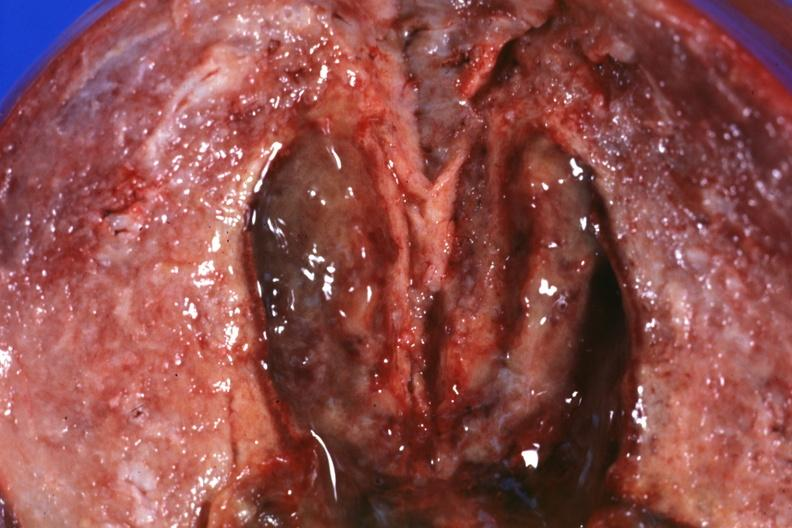s endometritis present?
Answer the question using a single word or phrase. Yes 